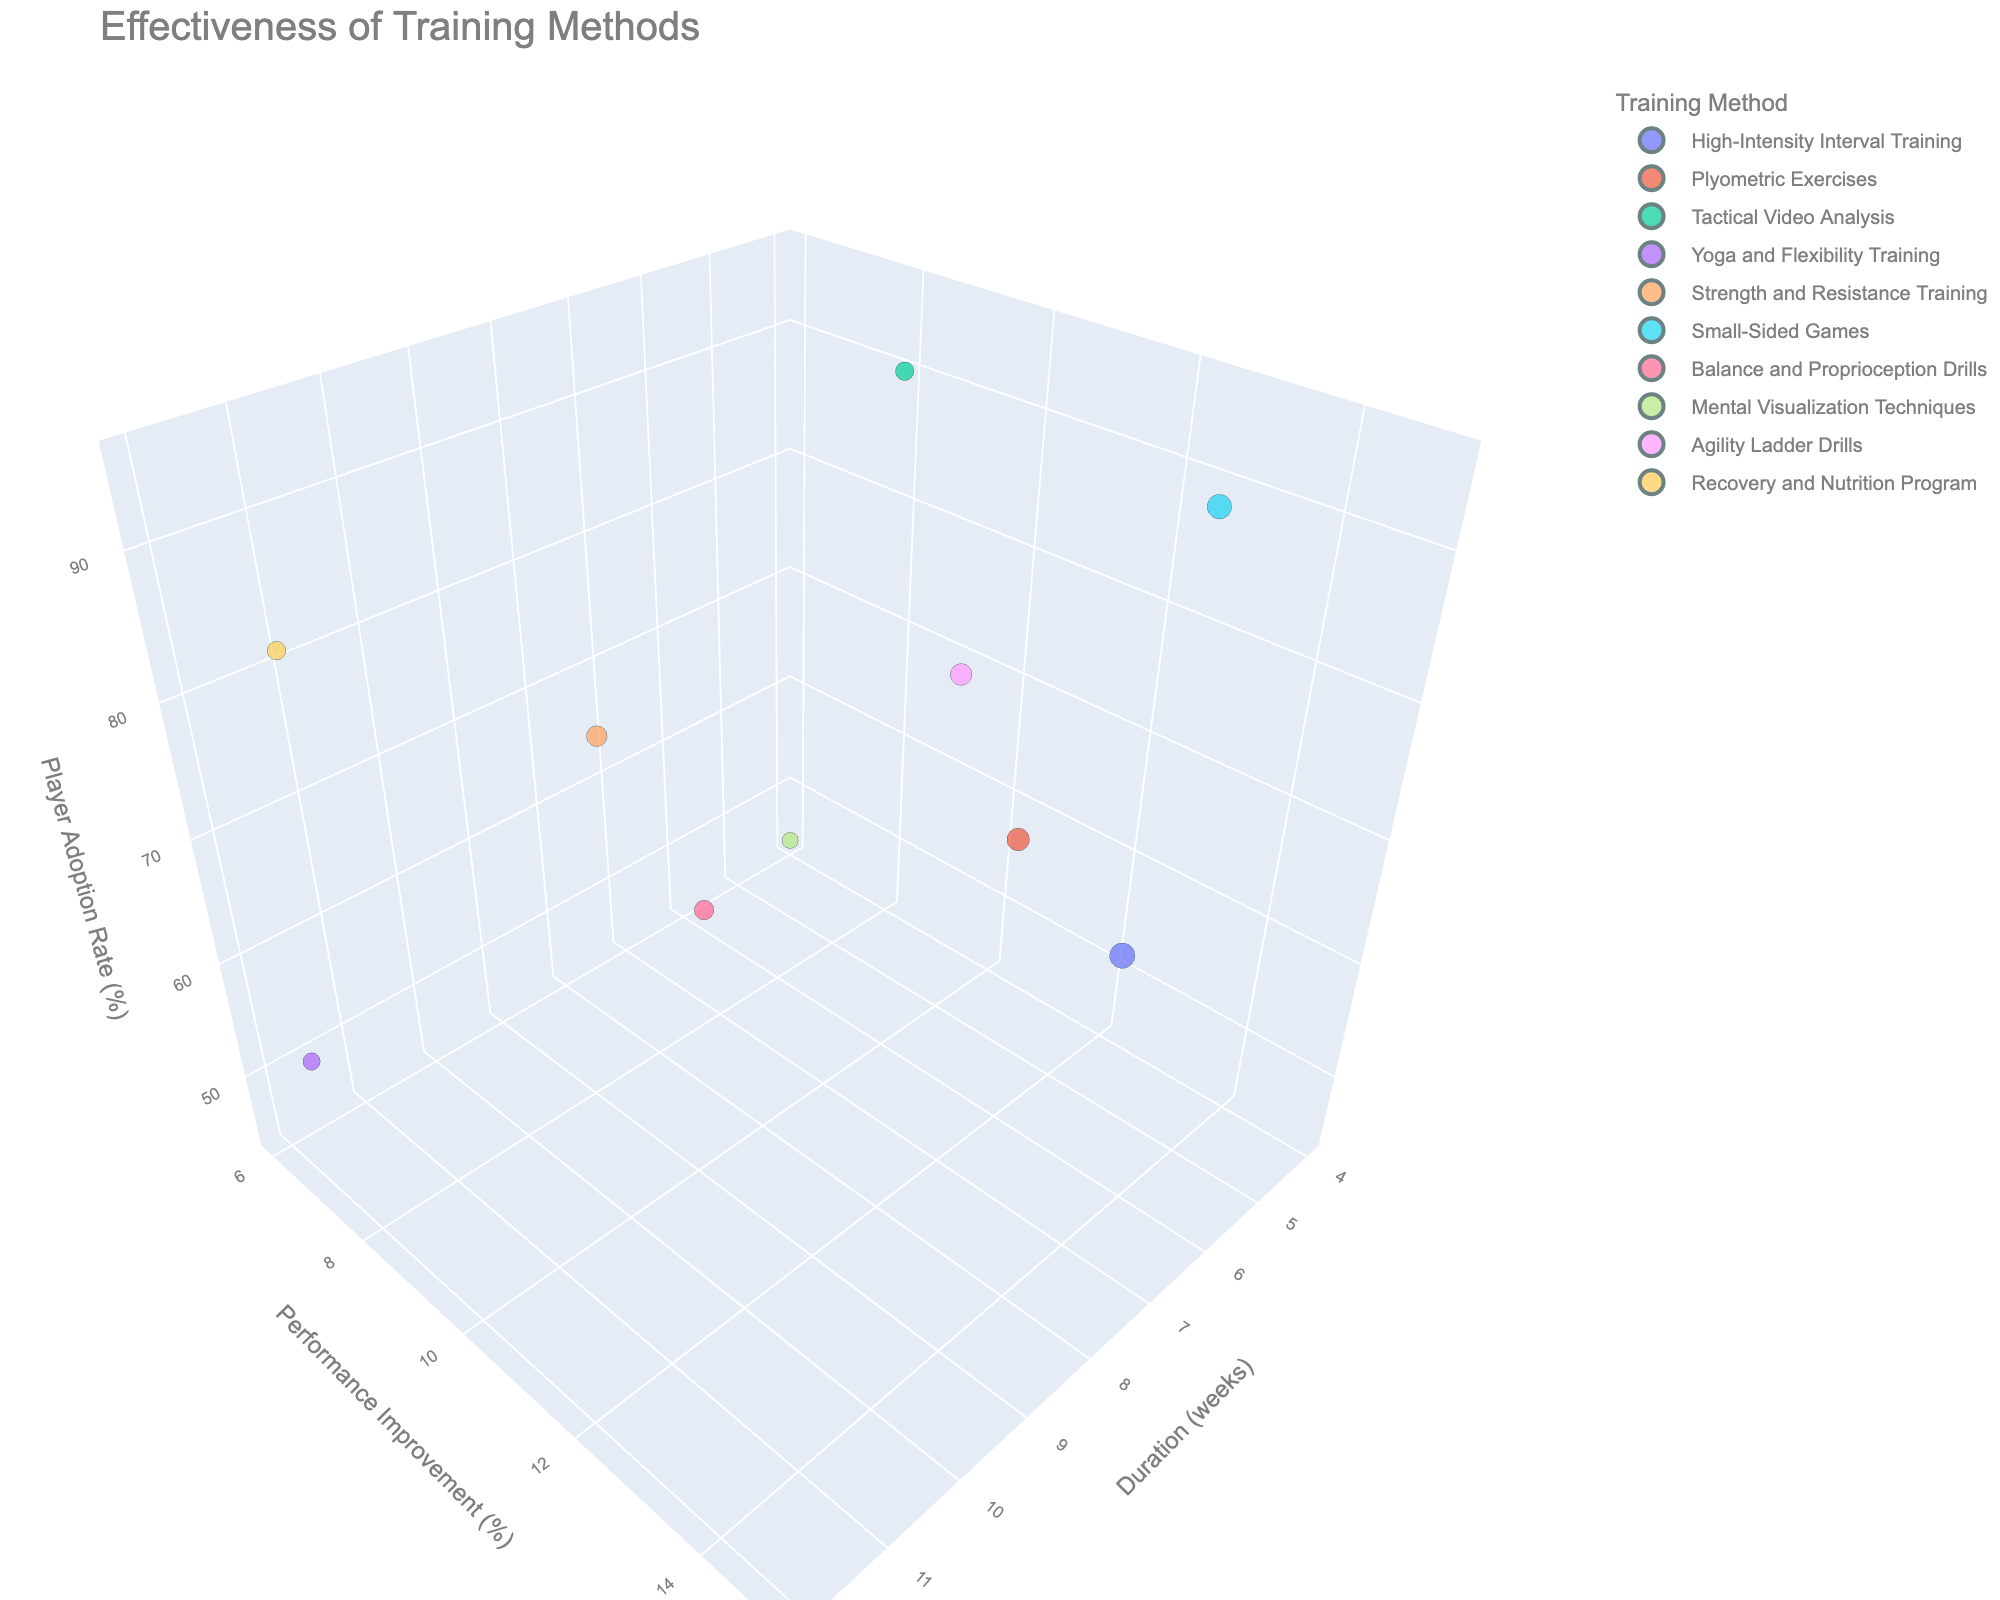What is the title of the plot? The title is displayed at the top of the figure.
Answer: Effectiveness of Training Methods Which training method results in the highest player adoption rate? By examining the z-axis, which represents player adoption rate, the highest value corresponds to the bubble representing 'Small-Sided Games'.
Answer: Small-Sided Games How many training methods have a duration of 6 weeks? Look at the x-axis for the value of 6 weeks and count the number of bubbles aligned with it.
Answer: 3 Which training method has the highest performance improvement percentage? Refer to the y-axis values; the highest percentage is 15%, which corresponds to 'High-Intensity Interval Training'.
Answer: High-Intensity Interval Training What is the total duration for all training methods combined? Sum the duration values for all methods: 8 + 6 + 4 + 12 + 10 + 6 + 8 + 4 + 6 + 12 = 76 weeks.
Answer: 76 weeks Which training methods have an adoption rate of more than 80%? Identify bubbles on the z-axis where the value exceeds 80%: 'Tactical Video Analysis', 'Strength and Resistance Training', 'Small-Sided Games', 'Recovery and Nutrition Program'.
Answer: Tactical Video Analysis, Strength and Resistance Training, Small-Sided Games, Recovery and Nutrition Program Which training method shows the smallest improvement in performance? The smallest value on the y-axis is 6%, corresponding to 'Mental Visualization Techniques'.
Answer: Mental Visualization Techniques What's the average performance improvement for all training methods? Calculate the average of the y-values: (15+12+8+7+10+14+9+6+11+8)/10 = 100/10 = 10%.
Answer: 10% How does the performance improvement of 'Yoga and Flexibility Training' compare to 'Plyometric Exercises'? Compare the y-values: 'Yoga and Flexibility Training' has 7%, while 'Plyometric Exercises' has 12%; 12% - 7% = 5% difference.
Answer: Plyometric Exercises is 5% higher Which training method has a longer duration but a lower adoption rate compared to 'Agility Ladder Drills'? 'Agility Ladder Drills' has a duration of 6 weeks and an adoption rate of 78%. 'Yoga and Flexibility Training' has a duration of 12 weeks and an adoption rate of 55%, which fits the criteria.
Answer: Yoga and Flexibility Training 